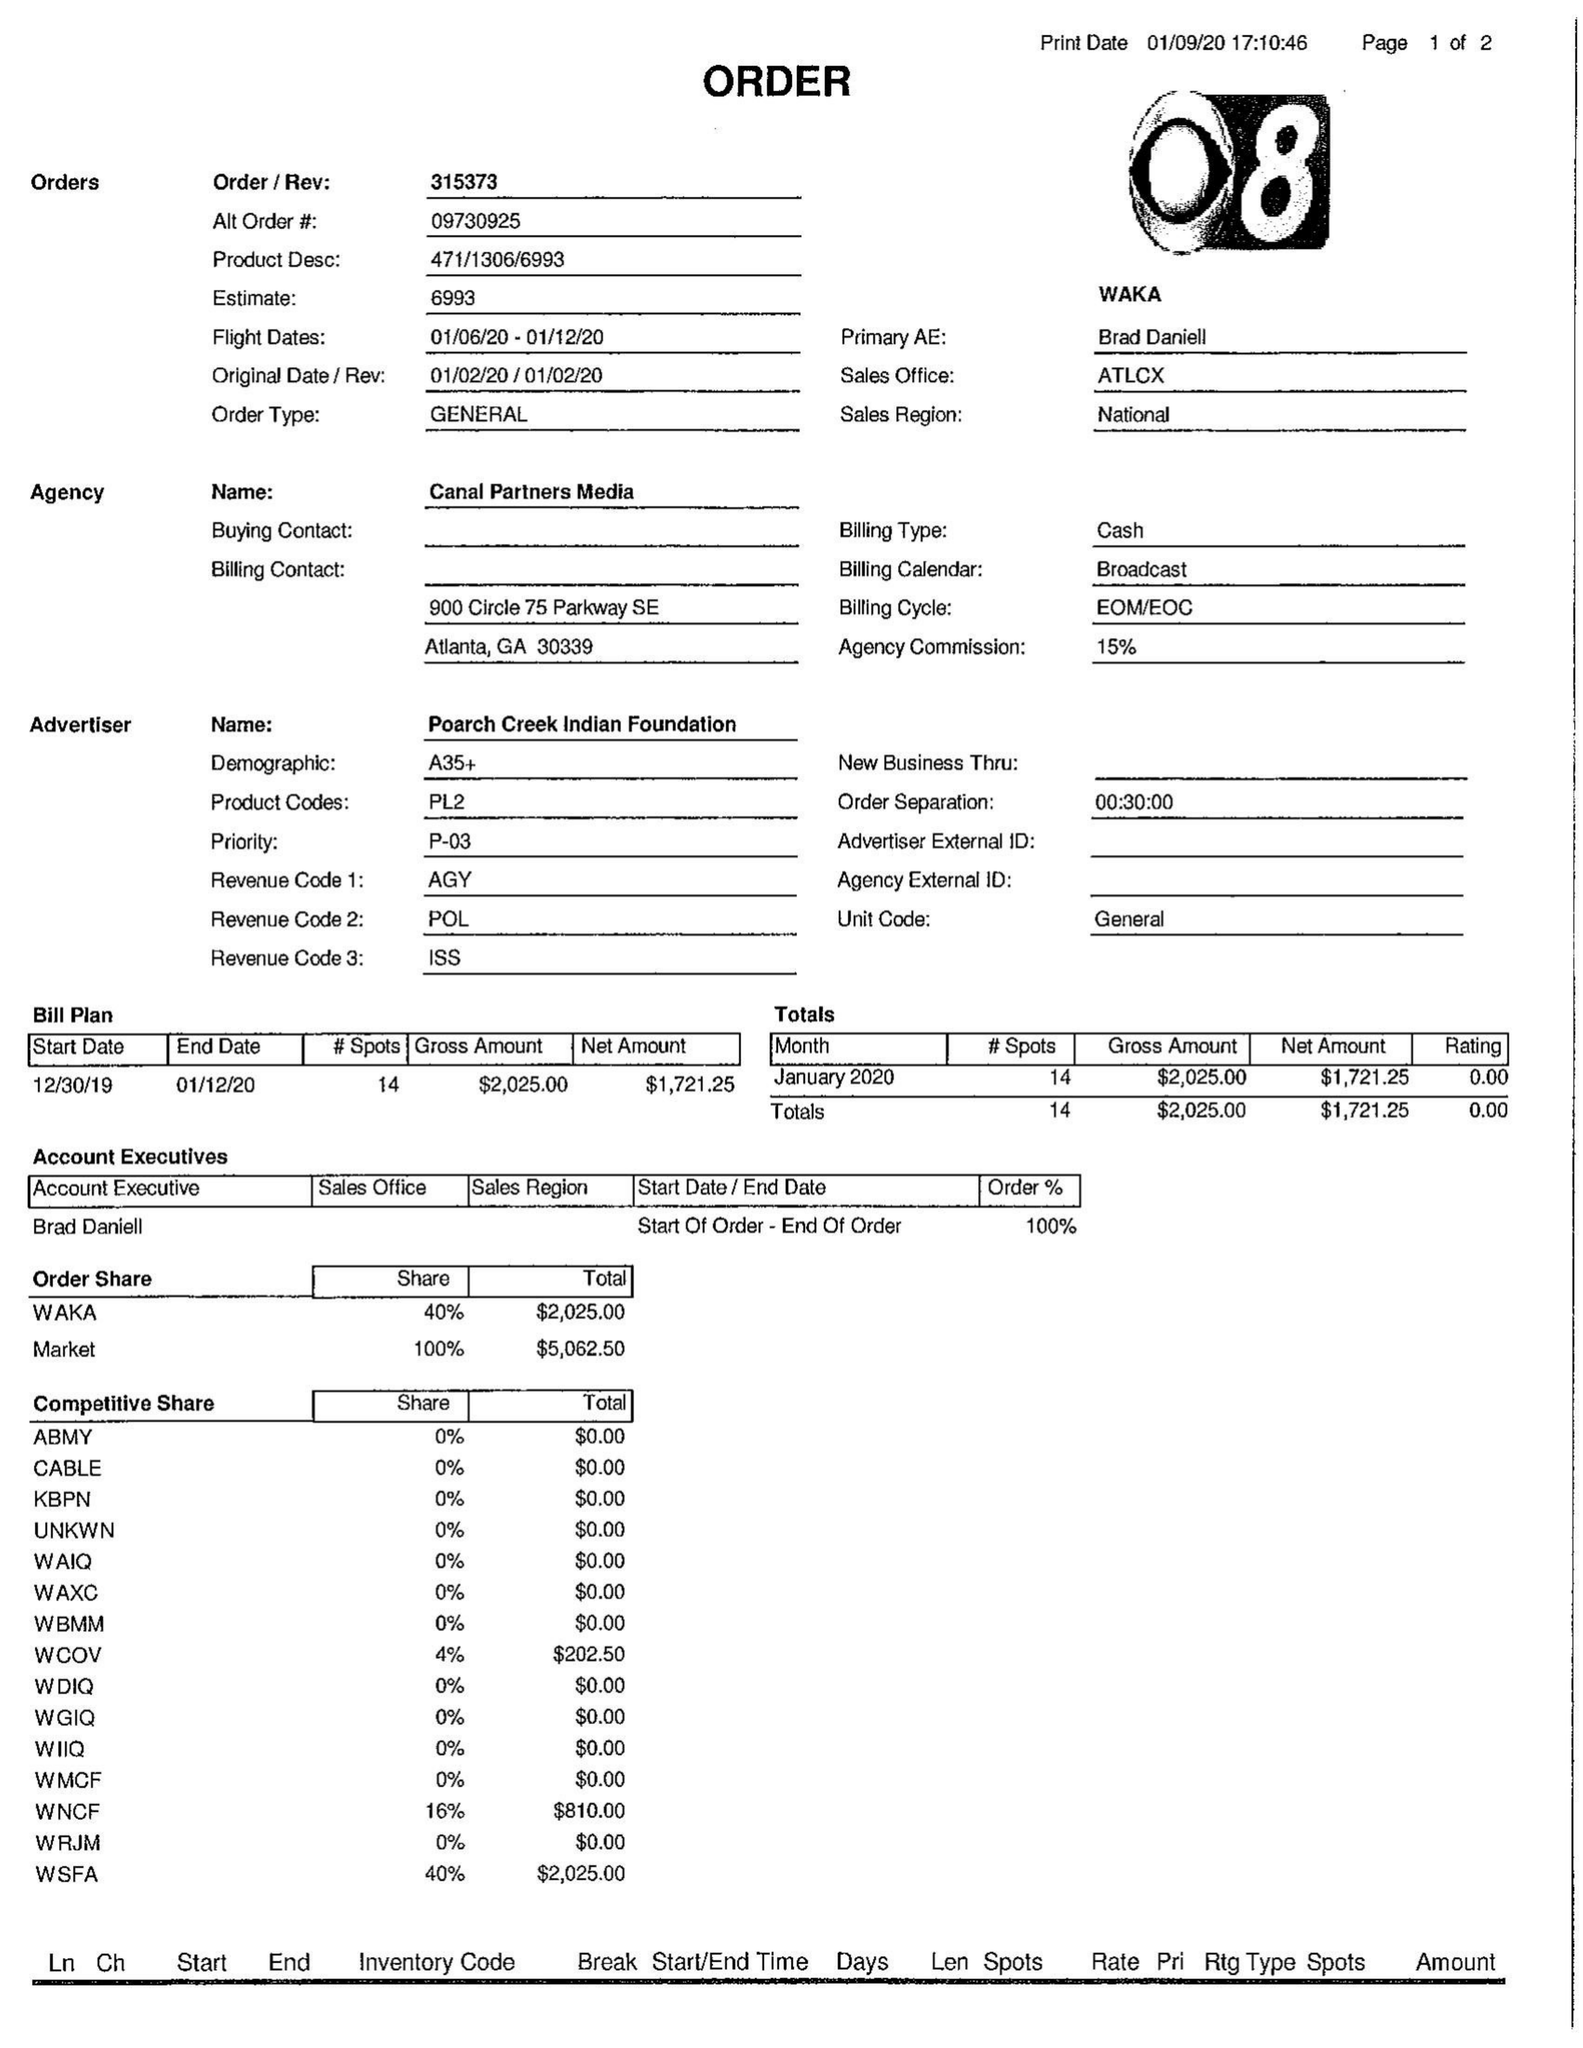What is the value for the gross_amount?
Answer the question using a single word or phrase. 2025.00 